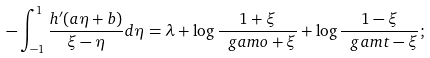Convert formula to latex. <formula><loc_0><loc_0><loc_500><loc_500>- \int _ { - 1 } ^ { 1 } \frac { h ^ { \prime } ( a \eta + b ) } { \xi - \eta } d \eta = \lambda + \log \frac { 1 + \xi } { \ g a m o + \xi } + \log \frac { 1 - \xi } { \ g a m t - \xi } ;</formula> 